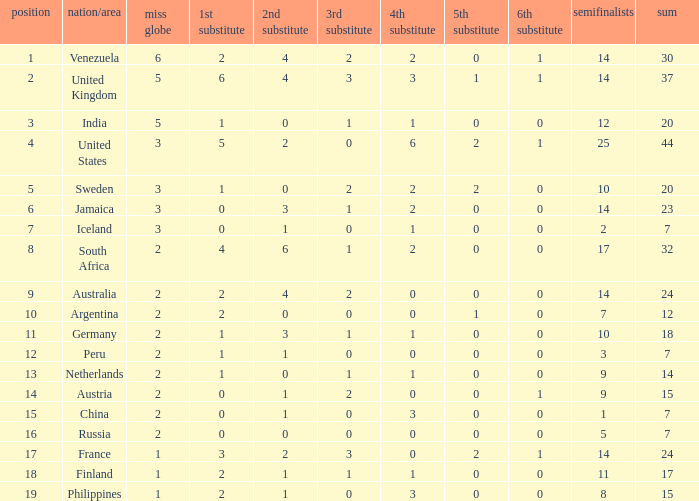Which countries have a 5th runner-up ranking is 2 and the 3rd runner-up ranking is 0 44.0. 